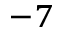<formula> <loc_0><loc_0><loc_500><loc_500>^ { - 7 }</formula> 